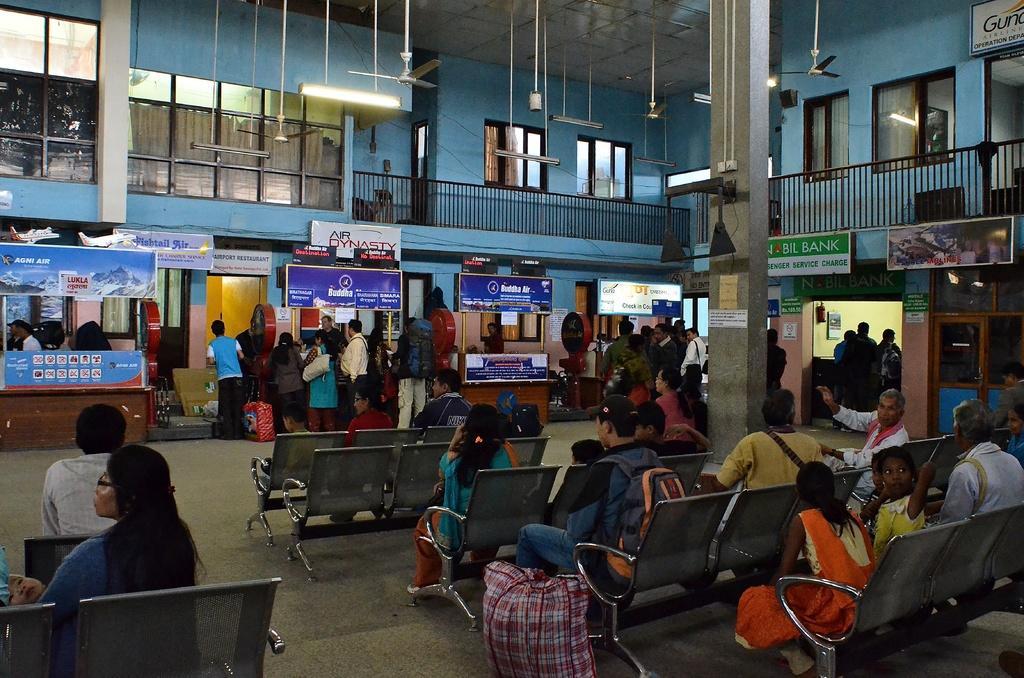Please provide a concise description of this image. In the center of the image we can see people standing. At the bottom some of them are sitting and there are counters. In the background there is a wall, doors and windows. At the top there are fans and we can see lights. 